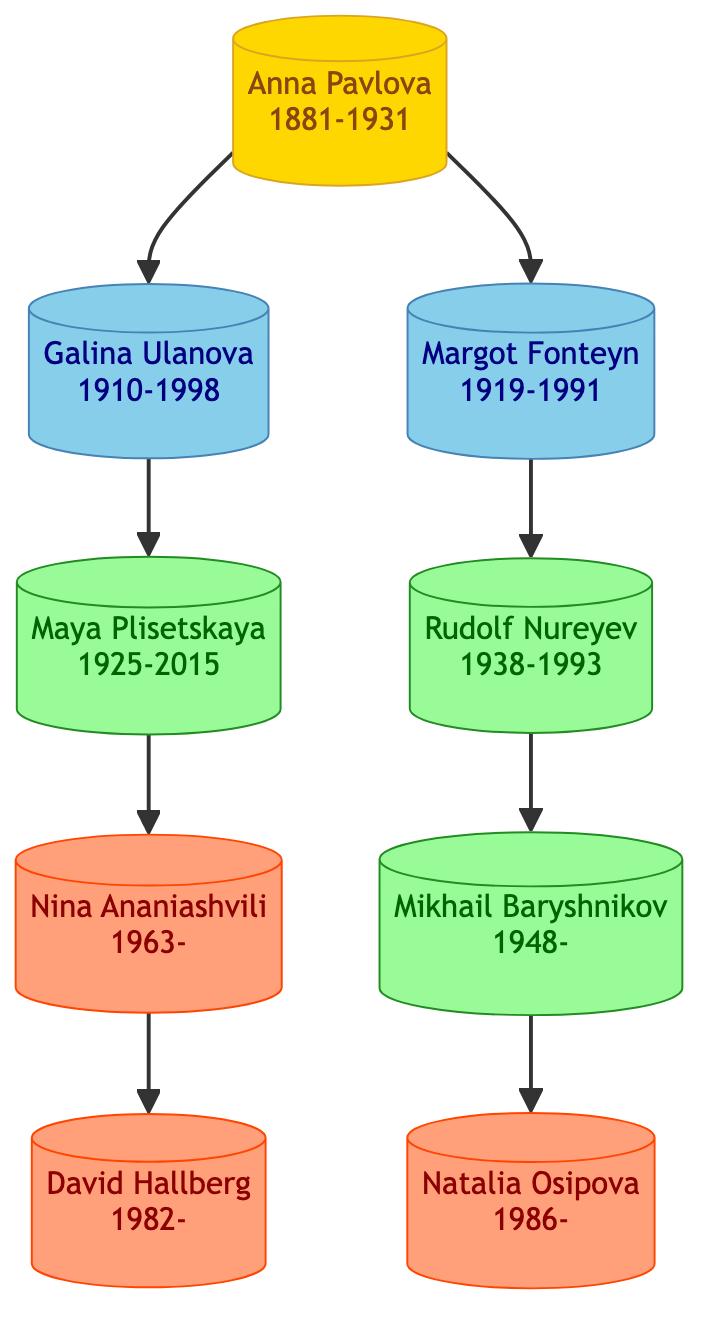What era did Anna Pavlova belong to? The diagram shows that Anna Pavlova is labeled with "Early 20th Century". Thus, her era is clearly indicated beside her name.
Answer: Early 20th Century Who was the mentor of Rudolf Nureyev? By examining the connections in the diagram, Rudolf Nureyev is shown to have a notable mentor represented by an arrow pointing towards him from Margot Fonteyn.
Answer: Margot Fonteyn How many principal dancers are listed in the diagram? The diagram contains a total of 9 nodes that represent distinct principal dancers. Counting these nodes gives the total number of principal dancers.
Answer: 9 Which dancer succeeded Galina Ulanova? The diagram indicates that Maya Plisetskaya is directly connected as a successor under Galina Ulanova, denoting that she is the dancer who followed her.
Answer: Maya Plisetskaya Name the modern-era dancer whose mentor is Nina Ananiashvili. The diagram shows that David Hallberg is connected as a successor to Nina Ananiashvili, indicating that he is the modern-era dancer mentored by her.
Answer: David Hallberg What is the relationship between Margot Fonteyn and Rudolf Nureyev? The diagram shows an arrow from Margot Fonteyn to Rudolf Nureyev, indicating that she is his mentor, thus establishing a direct mentorship connection between the two dancers.
Answer: Mentor How many successors did Anna Pavlova have? The diagram specifies that Anna Pavlova has two successors: Galina Ulanova and Margot Fonteyn, which can be counted by observing the arrows leading downward from her node.
Answer: 2 Which era includes Mikhail Baryshnikov? Looking at the diagram, Mikhail Baryshnikov is labeled with "Late 20th Century", indicating which era he is associated with.
Answer: Late 20th Century Who was the first mentor in the diagram? The first mentor, as depicted in the diagram, is Anna Pavlova, who has arrows pointing to her successors, indicating her role as a mentor in the family tree structure.
Answer: Anna Pavlova 